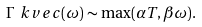<formula> <loc_0><loc_0><loc_500><loc_500>\Gamma _ { \ } k v e c ( \omega ) \sim \max ( \alpha T , \beta \omega ) .</formula> 